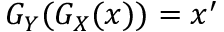<formula> <loc_0><loc_0><loc_500><loc_500>G _ { Y } ( G _ { X } ( x ) ) = x ^ { \prime }</formula> 